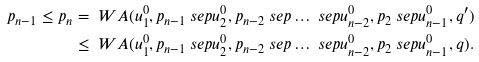Convert formula to latex. <formula><loc_0><loc_0><loc_500><loc_500>p _ { n - 1 } \leq p _ { n } & = \ W A ( u _ { 1 } ^ { 0 } , p _ { n - 1 } \ s e p u _ { 2 } ^ { 0 } , p _ { n - 2 } \ s e p \dots \ s e p u _ { n - 2 } ^ { 0 } , p _ { 2 } \ s e p u _ { n - 1 } ^ { 0 } , q ^ { \prime } ) \\ & \leq \ W A ( u _ { 1 } ^ { 0 } , p _ { n - 1 } \ s e p u _ { 2 } ^ { 0 } , p _ { n - 2 } \ s e p \dots \ s e p u _ { n - 2 } ^ { 0 } , p _ { 2 } \ s e p u _ { n - 1 } ^ { 0 } , q ) .</formula> 